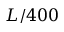<formula> <loc_0><loc_0><loc_500><loc_500>L / 4 0 0</formula> 